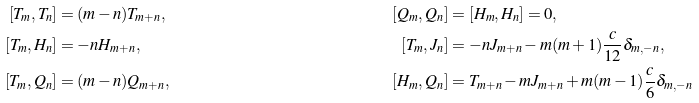Convert formula to latex. <formula><loc_0><loc_0><loc_500><loc_500>{ [ } T _ { m } , T _ { n } ] & = ( m - n ) T _ { m + n } , & [ Q _ { m } , Q _ { n } ] & = [ H _ { m } , H _ { n } ] = 0 , \\ { [ } T _ { m } , H _ { n } ] & = - n H _ { m + n } , & [ T _ { m } , J _ { n } ] & = - n J _ { m + n } - m ( m + 1 ) \frac { c } { 1 2 } \delta _ { m , - n } , \\ { [ } T _ { m } , Q _ { n } ] & = ( m - n ) Q _ { m + n } , & [ H _ { m } , Q _ { n } ] & = T _ { m + n } - m J _ { m + n } + m ( m - 1 ) \frac { c } { 6 } \delta _ { m , - n } \\</formula> 